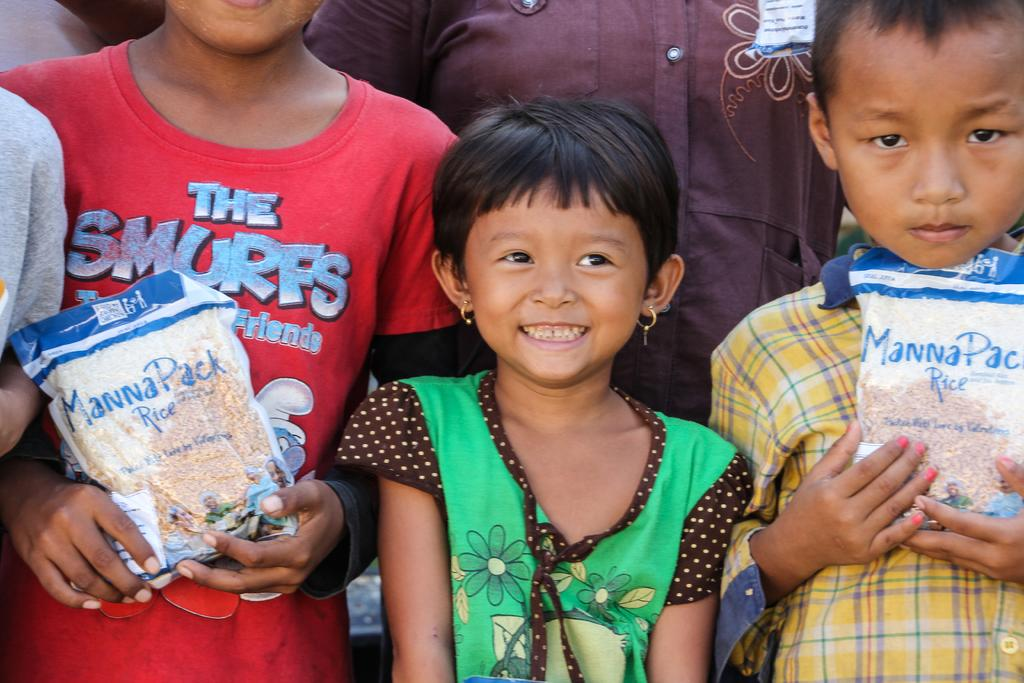How many people are in the image? There is a group of people in the image, but the exact number is not specified. What are some people doing in the image? Some people are holding pockets in their hands. What type of skirt is visible on the person in the image? There is no mention of a skirt or any clothing item in the provided facts, so it cannot be determined from the image. 